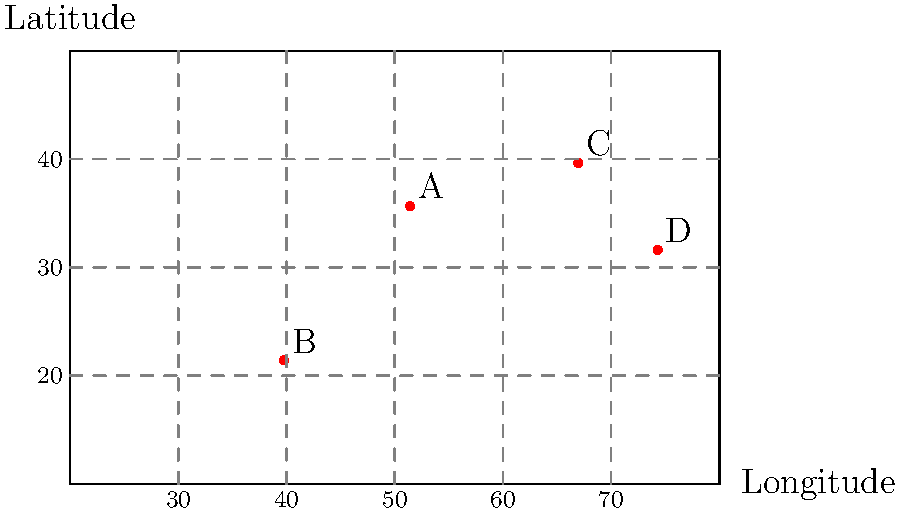The map above shows the locations of four major Sufi shrines (A, B, C, and D) in the Islamic world. Which of these shrines is located in Bukhara, Uzbekistan, a city known for its rich Sufi heritage and as a major center of Islamic learning during the Timurid Empire? To answer this question, we need to analyze the geographical locations of the given points and match them with our knowledge of Sufi shrines and the Timurid Empire:

1. Shrine A (51.42°E, 35.67°N): This location corresponds to Tehran, Iran. While Iran has many important Sufi shrines, this is not Bukhara.

2. Shrine B (39.77°E, 21.42°N): This location is in Saudi Arabia, likely Mecca. While important in Islam, it's not known for Sufi shrines or Timurid influence.

3. Shrine C (66.97°E, 39.65°N): This location matches Bukhara, Uzbekistan. Bukhara was a major center of Islamic learning and Sufism, especially during the Timurid Empire (14th-16th centuries). It's home to several important Sufi shrines, including the tomb of Baha-ud-Din Naqshband, founder of the Naqshbandi order.

4. Shrine D (74.31°E, 31.62°N): This location corresponds to Lahore, Pakistan. While it has Sufi heritage, it's not Bukhara.

Given the question's focus on Bukhara's significance in Sufism and its connection to the Timurid Empire, the correct answer must be Shrine C.
Answer: C 